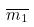Convert formula to latex. <formula><loc_0><loc_0><loc_500><loc_500>\overline { m _ { 1 } }</formula> 